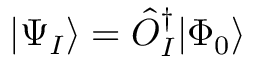Convert formula to latex. <formula><loc_0><loc_0><loc_500><loc_500>| \Psi _ { I } \rangle = \hat { O } _ { I } ^ { \dagger } | \Phi _ { 0 } \rangle</formula> 